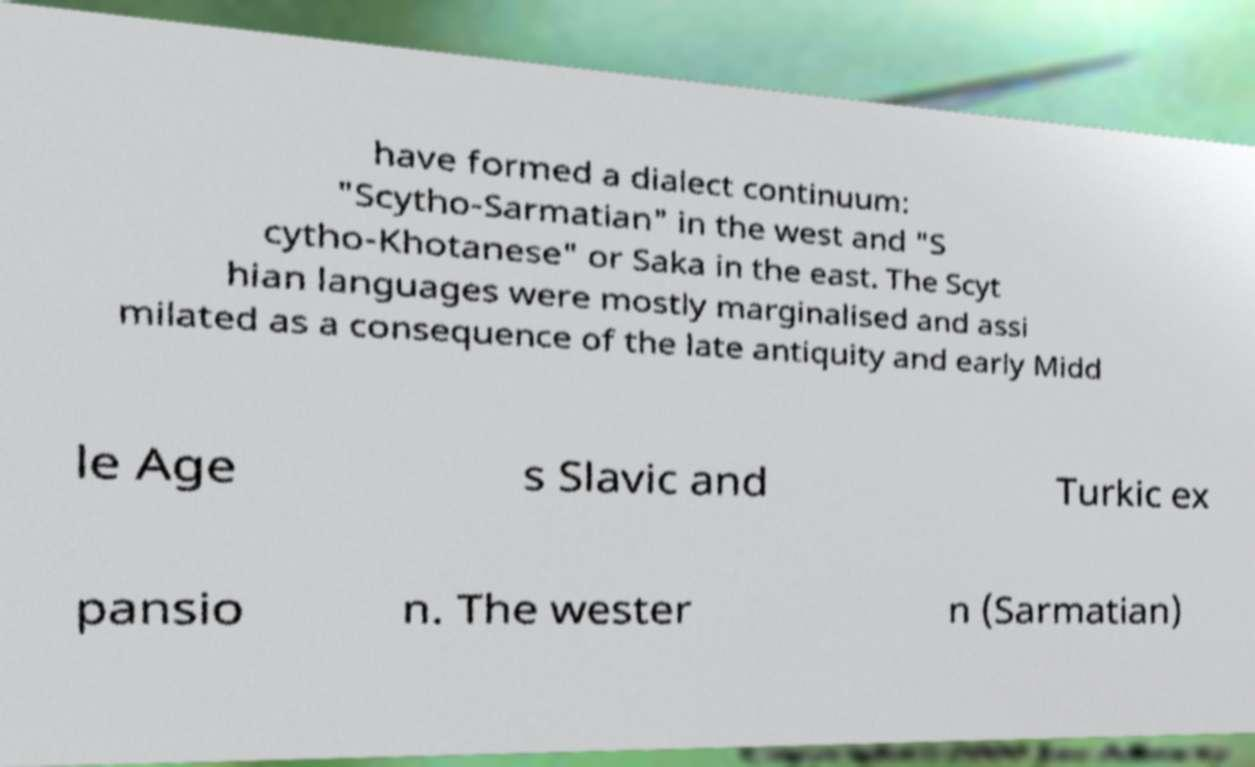Please identify and transcribe the text found in this image. have formed a dialect continuum: "Scytho-Sarmatian" in the west and "S cytho-Khotanese" or Saka in the east. The Scyt hian languages were mostly marginalised and assi milated as a consequence of the late antiquity and early Midd le Age s Slavic and Turkic ex pansio n. The wester n (Sarmatian) 